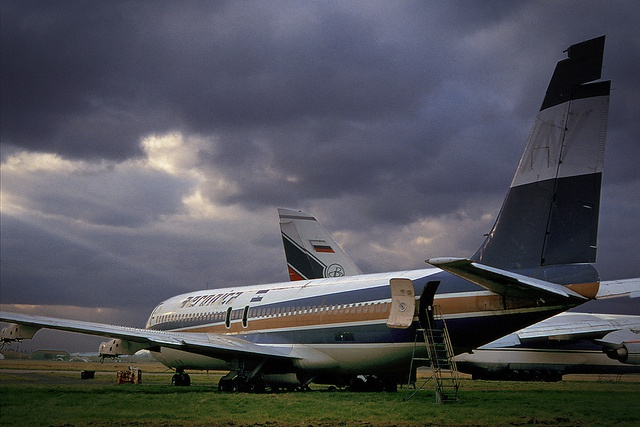Describe the objects in this image and their specific colors. I can see airplane in black, gray, and darkgray tones and airplane in black, gray, and darkgray tones in this image. 